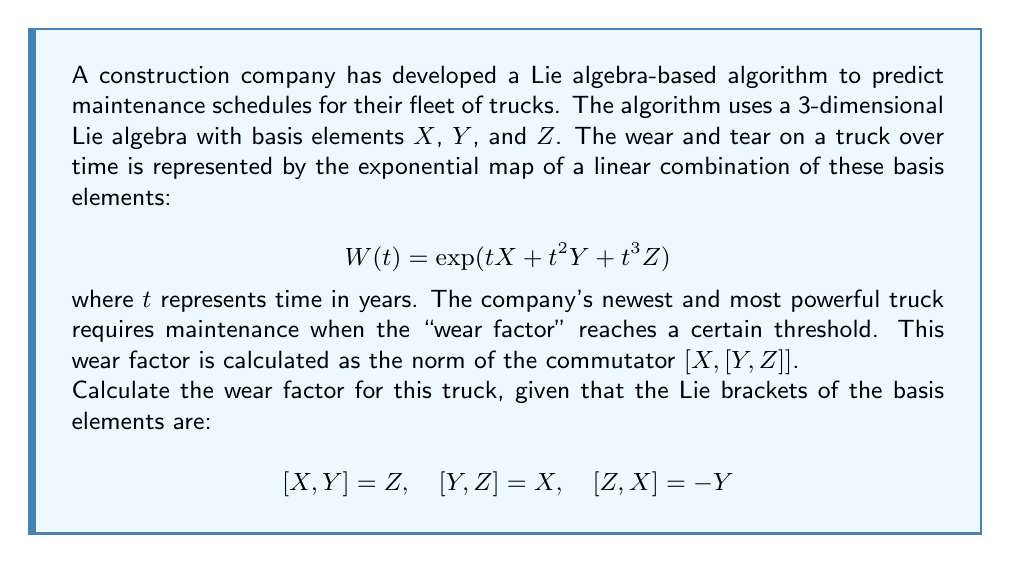What is the answer to this math problem? To solve this problem, we need to follow these steps:

1) First, we need to calculate the inner commutator $[Y, Z]$. We're given that $[Y, Z] = X$.

2) Next, we need to calculate the outer commutator $[X, [Y, Z]]$. This is equivalent to $[X, X]$ based on step 1.

3) We know that for any element $A$ in a Lie algebra, $[A, A] = 0$. Therefore, $[X, X] = 0$.

4) The wear factor is defined as the norm of this commutator. The norm of the zero element is always zero.

Let's go through this more formally:

$$\begin{align}
[Y, Z] &= X \\
[X, [Y, Z]] &= [X, X] \\
&= 0
\end{align}$$

The norm of the zero element in any vector space is always zero.

It's worth noting that while this result might seem counterintuitive for a wear factor, it's mathematically correct given the problem setup. In a more complex model, the wear factor might involve additional terms or a different combination of commutators.
Answer: The wear factor for the truck is 0. 